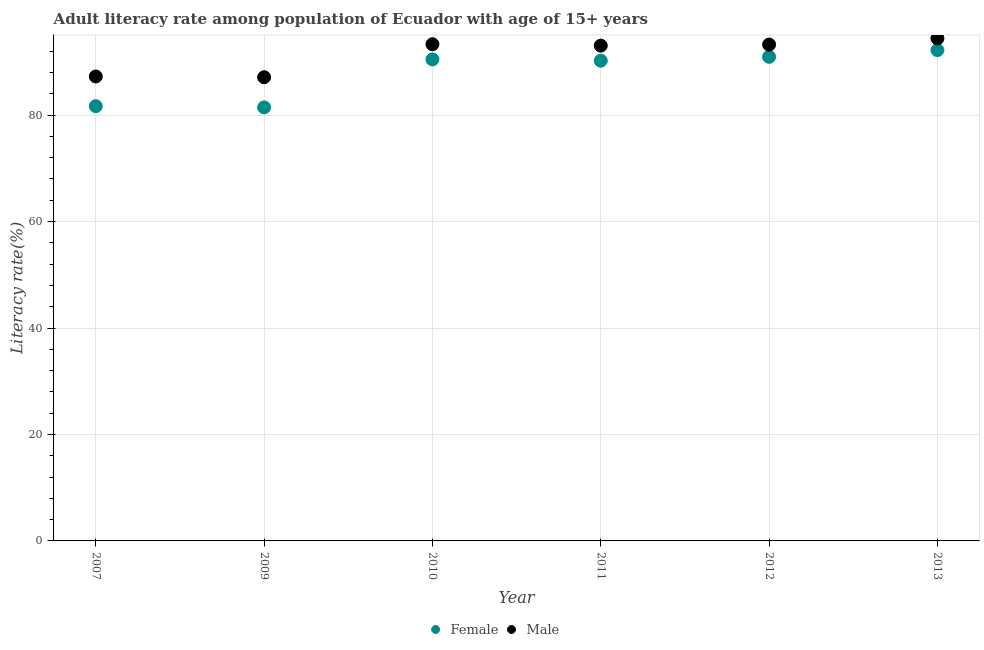Is the number of dotlines equal to the number of legend labels?
Keep it short and to the point. Yes. What is the female adult literacy rate in 2012?
Provide a short and direct response. 90.95. Across all years, what is the maximum male adult literacy rate?
Your answer should be very brief. 94.43. Across all years, what is the minimum female adult literacy rate?
Offer a very short reply. 81.45. What is the total female adult literacy rate in the graph?
Ensure brevity in your answer.  526.99. What is the difference between the female adult literacy rate in 2007 and that in 2012?
Provide a succinct answer. -9.27. What is the difference between the male adult literacy rate in 2007 and the female adult literacy rate in 2012?
Keep it short and to the point. -3.69. What is the average male adult literacy rate per year?
Provide a succinct answer. 91.4. In the year 2013, what is the difference between the male adult literacy rate and female adult literacy rate?
Provide a succinct answer. 2.21. What is the ratio of the female adult literacy rate in 2011 to that in 2012?
Keep it short and to the point. 0.99. Is the female adult literacy rate in 2009 less than that in 2011?
Offer a very short reply. Yes. Is the difference between the female adult literacy rate in 2007 and 2009 greater than the difference between the male adult literacy rate in 2007 and 2009?
Your answer should be compact. Yes. What is the difference between the highest and the second highest male adult literacy rate?
Provide a succinct answer. 1.11. What is the difference between the highest and the lowest male adult literacy rate?
Offer a very short reply. 7.31. In how many years, is the male adult literacy rate greater than the average male adult literacy rate taken over all years?
Give a very brief answer. 4. Does the male adult literacy rate monotonically increase over the years?
Give a very brief answer. No. Is the male adult literacy rate strictly greater than the female adult literacy rate over the years?
Your answer should be compact. Yes. Is the male adult literacy rate strictly less than the female adult literacy rate over the years?
Your answer should be very brief. No. How many years are there in the graph?
Provide a succinct answer. 6. What is the difference between two consecutive major ticks on the Y-axis?
Give a very brief answer. 20. Are the values on the major ticks of Y-axis written in scientific E-notation?
Ensure brevity in your answer.  No. Does the graph contain grids?
Provide a short and direct response. Yes. Where does the legend appear in the graph?
Your response must be concise. Bottom center. What is the title of the graph?
Provide a succinct answer. Adult literacy rate among population of Ecuador with age of 15+ years. Does "Canada" appear as one of the legend labels in the graph?
Keep it short and to the point. No. What is the label or title of the Y-axis?
Give a very brief answer. Literacy rate(%). What is the Literacy rate(%) of Female in 2007?
Give a very brief answer. 81.68. What is the Literacy rate(%) in Male in 2007?
Make the answer very short. 87.26. What is the Literacy rate(%) in Female in 2009?
Your response must be concise. 81.45. What is the Literacy rate(%) of Male in 2009?
Offer a terse response. 87.12. What is the Literacy rate(%) of Female in 2010?
Your answer should be compact. 90.47. What is the Literacy rate(%) of Male in 2010?
Your response must be concise. 93.32. What is the Literacy rate(%) of Female in 2011?
Offer a very short reply. 90.22. What is the Literacy rate(%) of Male in 2011?
Ensure brevity in your answer.  93.05. What is the Literacy rate(%) of Female in 2012?
Offer a terse response. 90.95. What is the Literacy rate(%) of Male in 2012?
Keep it short and to the point. 93.25. What is the Literacy rate(%) in Female in 2013?
Give a very brief answer. 92.22. What is the Literacy rate(%) of Male in 2013?
Offer a terse response. 94.43. Across all years, what is the maximum Literacy rate(%) in Female?
Provide a succinct answer. 92.22. Across all years, what is the maximum Literacy rate(%) in Male?
Give a very brief answer. 94.43. Across all years, what is the minimum Literacy rate(%) of Female?
Provide a short and direct response. 81.45. Across all years, what is the minimum Literacy rate(%) in Male?
Offer a terse response. 87.12. What is the total Literacy rate(%) in Female in the graph?
Offer a very short reply. 526.99. What is the total Literacy rate(%) in Male in the graph?
Provide a short and direct response. 548.43. What is the difference between the Literacy rate(%) in Female in 2007 and that in 2009?
Make the answer very short. 0.23. What is the difference between the Literacy rate(%) of Male in 2007 and that in 2009?
Provide a succinct answer. 0.14. What is the difference between the Literacy rate(%) of Female in 2007 and that in 2010?
Offer a very short reply. -8.79. What is the difference between the Literacy rate(%) of Male in 2007 and that in 2010?
Provide a succinct answer. -6.06. What is the difference between the Literacy rate(%) in Female in 2007 and that in 2011?
Your response must be concise. -8.54. What is the difference between the Literacy rate(%) in Male in 2007 and that in 2011?
Provide a succinct answer. -5.79. What is the difference between the Literacy rate(%) of Female in 2007 and that in 2012?
Ensure brevity in your answer.  -9.27. What is the difference between the Literacy rate(%) in Male in 2007 and that in 2012?
Give a very brief answer. -5.99. What is the difference between the Literacy rate(%) in Female in 2007 and that in 2013?
Offer a very short reply. -10.54. What is the difference between the Literacy rate(%) of Male in 2007 and that in 2013?
Your answer should be very brief. -7.17. What is the difference between the Literacy rate(%) in Female in 2009 and that in 2010?
Offer a very short reply. -9.02. What is the difference between the Literacy rate(%) of Male in 2009 and that in 2010?
Keep it short and to the point. -6.2. What is the difference between the Literacy rate(%) in Female in 2009 and that in 2011?
Your answer should be very brief. -8.77. What is the difference between the Literacy rate(%) in Male in 2009 and that in 2011?
Make the answer very short. -5.93. What is the difference between the Literacy rate(%) in Female in 2009 and that in 2012?
Offer a very short reply. -9.5. What is the difference between the Literacy rate(%) in Male in 2009 and that in 2012?
Your response must be concise. -6.14. What is the difference between the Literacy rate(%) of Female in 2009 and that in 2013?
Provide a short and direct response. -10.77. What is the difference between the Literacy rate(%) in Male in 2009 and that in 2013?
Make the answer very short. -7.31. What is the difference between the Literacy rate(%) in Female in 2010 and that in 2011?
Ensure brevity in your answer.  0.25. What is the difference between the Literacy rate(%) of Male in 2010 and that in 2011?
Provide a succinct answer. 0.26. What is the difference between the Literacy rate(%) in Female in 2010 and that in 2012?
Give a very brief answer. -0.48. What is the difference between the Literacy rate(%) of Male in 2010 and that in 2012?
Make the answer very short. 0.06. What is the difference between the Literacy rate(%) of Female in 2010 and that in 2013?
Provide a short and direct response. -1.75. What is the difference between the Literacy rate(%) in Male in 2010 and that in 2013?
Your response must be concise. -1.11. What is the difference between the Literacy rate(%) of Female in 2011 and that in 2012?
Provide a short and direct response. -0.73. What is the difference between the Literacy rate(%) in Male in 2011 and that in 2012?
Your answer should be compact. -0.2. What is the difference between the Literacy rate(%) in Female in 2011 and that in 2013?
Your response must be concise. -2. What is the difference between the Literacy rate(%) of Male in 2011 and that in 2013?
Ensure brevity in your answer.  -1.37. What is the difference between the Literacy rate(%) in Female in 2012 and that in 2013?
Offer a very short reply. -1.27. What is the difference between the Literacy rate(%) in Male in 2012 and that in 2013?
Your response must be concise. -1.17. What is the difference between the Literacy rate(%) of Female in 2007 and the Literacy rate(%) of Male in 2009?
Your response must be concise. -5.44. What is the difference between the Literacy rate(%) of Female in 2007 and the Literacy rate(%) of Male in 2010?
Your response must be concise. -11.64. What is the difference between the Literacy rate(%) of Female in 2007 and the Literacy rate(%) of Male in 2011?
Your answer should be very brief. -11.37. What is the difference between the Literacy rate(%) in Female in 2007 and the Literacy rate(%) in Male in 2012?
Keep it short and to the point. -11.57. What is the difference between the Literacy rate(%) in Female in 2007 and the Literacy rate(%) in Male in 2013?
Offer a very short reply. -12.75. What is the difference between the Literacy rate(%) in Female in 2009 and the Literacy rate(%) in Male in 2010?
Provide a short and direct response. -11.87. What is the difference between the Literacy rate(%) of Female in 2009 and the Literacy rate(%) of Male in 2011?
Ensure brevity in your answer.  -11.6. What is the difference between the Literacy rate(%) of Female in 2009 and the Literacy rate(%) of Male in 2012?
Provide a short and direct response. -11.8. What is the difference between the Literacy rate(%) in Female in 2009 and the Literacy rate(%) in Male in 2013?
Your answer should be very brief. -12.97. What is the difference between the Literacy rate(%) of Female in 2010 and the Literacy rate(%) of Male in 2011?
Give a very brief answer. -2.58. What is the difference between the Literacy rate(%) of Female in 2010 and the Literacy rate(%) of Male in 2012?
Make the answer very short. -2.78. What is the difference between the Literacy rate(%) of Female in 2010 and the Literacy rate(%) of Male in 2013?
Ensure brevity in your answer.  -3.96. What is the difference between the Literacy rate(%) in Female in 2011 and the Literacy rate(%) in Male in 2012?
Provide a succinct answer. -3.03. What is the difference between the Literacy rate(%) in Female in 2011 and the Literacy rate(%) in Male in 2013?
Make the answer very short. -4.2. What is the difference between the Literacy rate(%) in Female in 2012 and the Literacy rate(%) in Male in 2013?
Offer a terse response. -3.47. What is the average Literacy rate(%) in Female per year?
Make the answer very short. 87.83. What is the average Literacy rate(%) of Male per year?
Keep it short and to the point. 91.4. In the year 2007, what is the difference between the Literacy rate(%) in Female and Literacy rate(%) in Male?
Your answer should be very brief. -5.58. In the year 2009, what is the difference between the Literacy rate(%) in Female and Literacy rate(%) in Male?
Your response must be concise. -5.67. In the year 2010, what is the difference between the Literacy rate(%) of Female and Literacy rate(%) of Male?
Keep it short and to the point. -2.85. In the year 2011, what is the difference between the Literacy rate(%) in Female and Literacy rate(%) in Male?
Ensure brevity in your answer.  -2.83. In the year 2012, what is the difference between the Literacy rate(%) in Female and Literacy rate(%) in Male?
Offer a very short reply. -2.3. In the year 2013, what is the difference between the Literacy rate(%) of Female and Literacy rate(%) of Male?
Offer a very short reply. -2.21. What is the ratio of the Literacy rate(%) of Female in 2007 to that in 2009?
Your answer should be very brief. 1. What is the ratio of the Literacy rate(%) in Male in 2007 to that in 2009?
Ensure brevity in your answer.  1. What is the ratio of the Literacy rate(%) in Female in 2007 to that in 2010?
Your response must be concise. 0.9. What is the ratio of the Literacy rate(%) in Male in 2007 to that in 2010?
Offer a very short reply. 0.94. What is the ratio of the Literacy rate(%) in Female in 2007 to that in 2011?
Your answer should be compact. 0.91. What is the ratio of the Literacy rate(%) of Male in 2007 to that in 2011?
Provide a short and direct response. 0.94. What is the ratio of the Literacy rate(%) in Female in 2007 to that in 2012?
Ensure brevity in your answer.  0.9. What is the ratio of the Literacy rate(%) in Male in 2007 to that in 2012?
Your answer should be compact. 0.94. What is the ratio of the Literacy rate(%) of Female in 2007 to that in 2013?
Your answer should be compact. 0.89. What is the ratio of the Literacy rate(%) in Male in 2007 to that in 2013?
Your response must be concise. 0.92. What is the ratio of the Literacy rate(%) of Female in 2009 to that in 2010?
Your answer should be very brief. 0.9. What is the ratio of the Literacy rate(%) of Male in 2009 to that in 2010?
Offer a very short reply. 0.93. What is the ratio of the Literacy rate(%) of Female in 2009 to that in 2011?
Provide a succinct answer. 0.9. What is the ratio of the Literacy rate(%) in Male in 2009 to that in 2011?
Keep it short and to the point. 0.94. What is the ratio of the Literacy rate(%) of Female in 2009 to that in 2012?
Offer a very short reply. 0.9. What is the ratio of the Literacy rate(%) in Male in 2009 to that in 2012?
Provide a short and direct response. 0.93. What is the ratio of the Literacy rate(%) of Female in 2009 to that in 2013?
Your answer should be compact. 0.88. What is the ratio of the Literacy rate(%) in Male in 2009 to that in 2013?
Provide a short and direct response. 0.92. What is the ratio of the Literacy rate(%) of Female in 2010 to that in 2011?
Offer a terse response. 1. What is the ratio of the Literacy rate(%) of Male in 2010 to that in 2012?
Your response must be concise. 1. What is the ratio of the Literacy rate(%) in Female in 2010 to that in 2013?
Ensure brevity in your answer.  0.98. What is the ratio of the Literacy rate(%) in Male in 2010 to that in 2013?
Give a very brief answer. 0.99. What is the ratio of the Literacy rate(%) of Female in 2011 to that in 2012?
Provide a short and direct response. 0.99. What is the ratio of the Literacy rate(%) of Female in 2011 to that in 2013?
Your response must be concise. 0.98. What is the ratio of the Literacy rate(%) in Male in 2011 to that in 2013?
Your answer should be compact. 0.99. What is the ratio of the Literacy rate(%) of Female in 2012 to that in 2013?
Provide a short and direct response. 0.99. What is the ratio of the Literacy rate(%) in Male in 2012 to that in 2013?
Your answer should be very brief. 0.99. What is the difference between the highest and the second highest Literacy rate(%) in Female?
Offer a terse response. 1.27. What is the difference between the highest and the second highest Literacy rate(%) of Male?
Ensure brevity in your answer.  1.11. What is the difference between the highest and the lowest Literacy rate(%) of Female?
Keep it short and to the point. 10.77. What is the difference between the highest and the lowest Literacy rate(%) of Male?
Offer a very short reply. 7.31. 